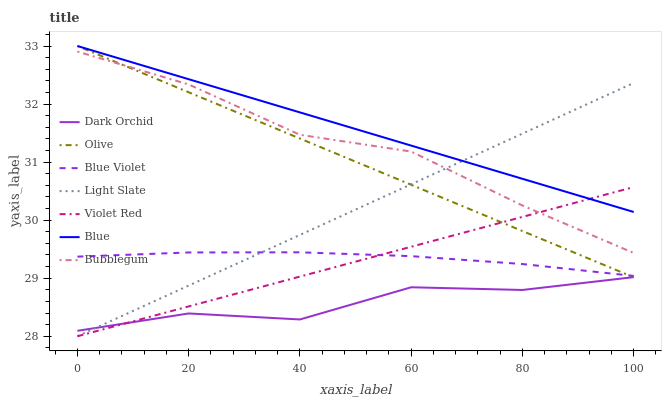Does Dark Orchid have the minimum area under the curve?
Answer yes or no. Yes. Does Blue have the maximum area under the curve?
Answer yes or no. Yes. Does Violet Red have the minimum area under the curve?
Answer yes or no. No. Does Violet Red have the maximum area under the curve?
Answer yes or no. No. Is Violet Red the smoothest?
Answer yes or no. Yes. Is Dark Orchid the roughest?
Answer yes or no. Yes. Is Light Slate the smoothest?
Answer yes or no. No. Is Light Slate the roughest?
Answer yes or no. No. Does Dark Orchid have the lowest value?
Answer yes or no. No. Does Olive have the highest value?
Answer yes or no. Yes. Does Violet Red have the highest value?
Answer yes or no. No. Is Dark Orchid less than Bubblegum?
Answer yes or no. Yes. Is Blue greater than Dark Orchid?
Answer yes or no. Yes. Does Dark Orchid intersect Bubblegum?
Answer yes or no. No. 